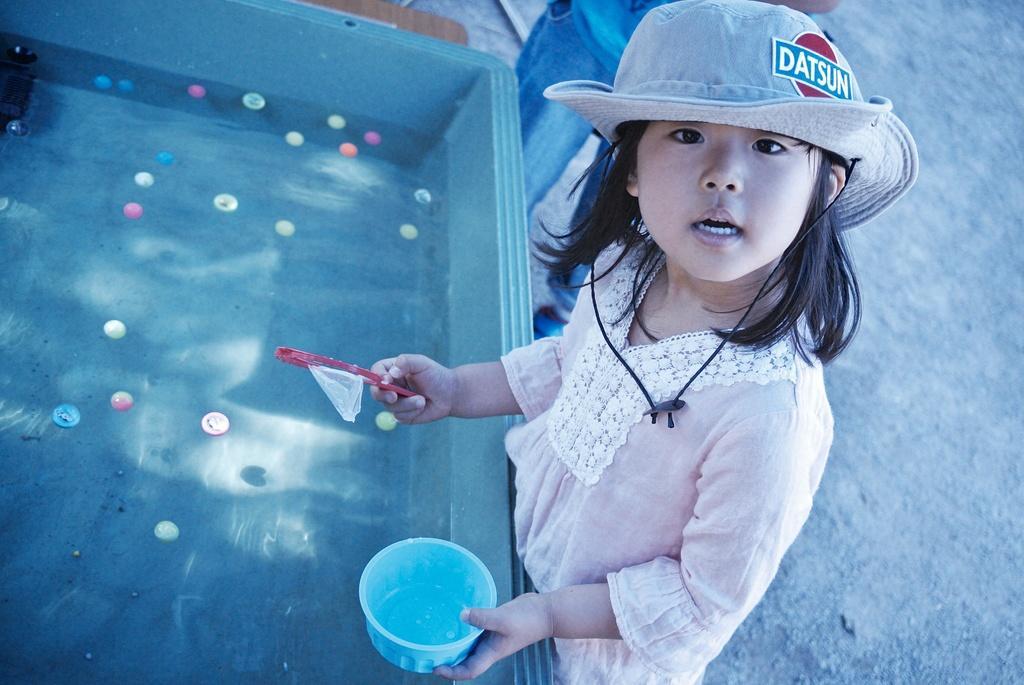Please provide a concise description of this image. In this image we can see a girl, she is wearing a hat, there is a cup, and an object in her hands, in front of her we can see the water in the tub, there are some objects floating on the water. 